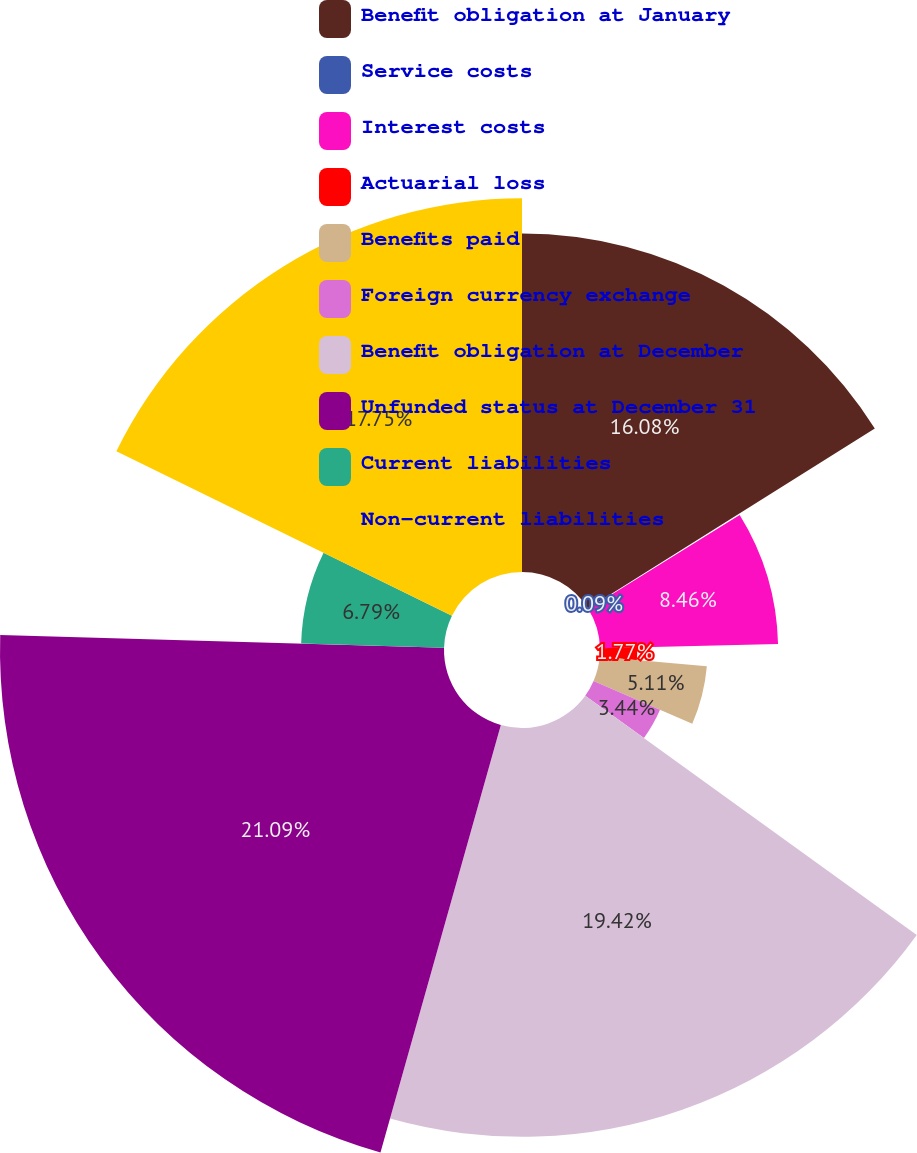<chart> <loc_0><loc_0><loc_500><loc_500><pie_chart><fcel>Benefit obligation at January<fcel>Service costs<fcel>Interest costs<fcel>Actuarial loss<fcel>Benefits paid<fcel>Foreign currency exchange<fcel>Benefit obligation at December<fcel>Unfunded status at December 31<fcel>Current liabilities<fcel>Non-current liabilities<nl><fcel>16.08%<fcel>0.09%<fcel>8.46%<fcel>1.77%<fcel>5.11%<fcel>3.44%<fcel>19.42%<fcel>21.09%<fcel>6.79%<fcel>17.75%<nl></chart> 